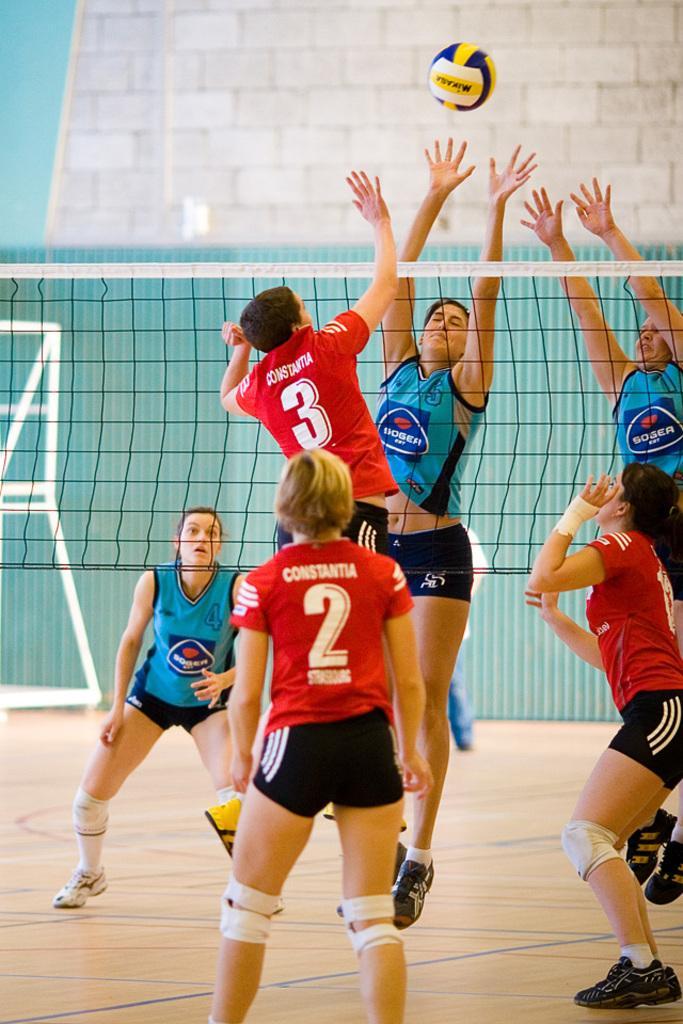Can you describe this image briefly? In this picture I can see there are few people playing throw ball and there is a net in between and there are few people standing behind the net, they are wearing blue jersey. The persons in front of the net are wearing red color jersey. In the backdrop I can see there is a blue color wall. 